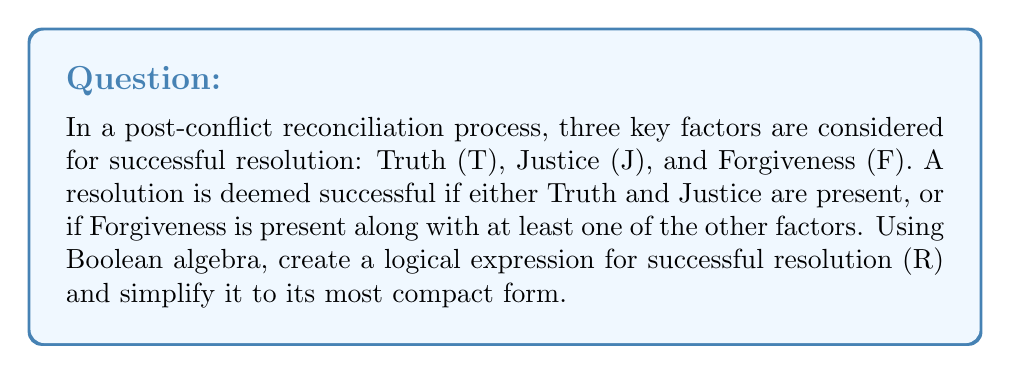What is the answer to this math problem? Let's approach this problem step by step:

1) First, we need to translate the given conditions into a Boolean expression:
   R = (T AND J) OR (F AND (T OR J))

2) We can represent this using Boolean algebra notation:
   $$R = (T \land J) \lor (F \land (T \lor J))$$

3) To simplify this expression, we can use the distributive law:
   $$R = (T \land J) \lor (F \land T) \lor (F \land J)$$

4) Now, we can use the associative law to rearrange the terms:
   $$R = (T \land J) \lor (T \land F) \lor (F \land J)$$

5) Using the distributive law again, we can factor out T:
   $$R = T \land (J \lor F) \lor (F \land J)$$

6) The expression $(J \lor F)$ includes all possibilities where either J or F is true, which is already covered by the last term $(F \land J)$. Therefore, we can simplify further:
   $$R = T \lor (F \land J)$$

7) This is the most compact form of the expression using standard Boolean operations.

This simplified expression means that a successful resolution (R) occurs when either Truth (T) is present, or when both Forgiveness (F) and Justice (J) are present.
Answer: $$R = T \lor (F \land J)$$ 